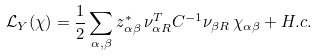Convert formula to latex. <formula><loc_0><loc_0><loc_500><loc_500>\mathcal { L } _ { Y } ( \chi ) = \frac { 1 } { 2 } \sum _ { \alpha , \beta } z _ { \alpha \beta } ^ { * } \, \nu _ { \alpha R } ^ { T } C ^ { - 1 } \nu _ { \beta R } \, \chi _ { \alpha \beta } + H . c .</formula> 